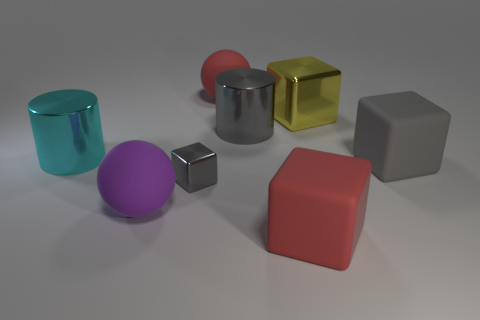How many gray blocks must be subtracted to get 1 gray blocks? 1 Subtract all gray balls. Subtract all green cylinders. How many balls are left? 2 Add 2 purple objects. How many objects exist? 10 Subtract all spheres. How many objects are left? 6 Add 3 big cylinders. How many big cylinders are left? 5 Add 1 large brown spheres. How many large brown spheres exist? 1 Subtract 0 gray balls. How many objects are left? 8 Subtract all large brown objects. Subtract all large red cubes. How many objects are left? 7 